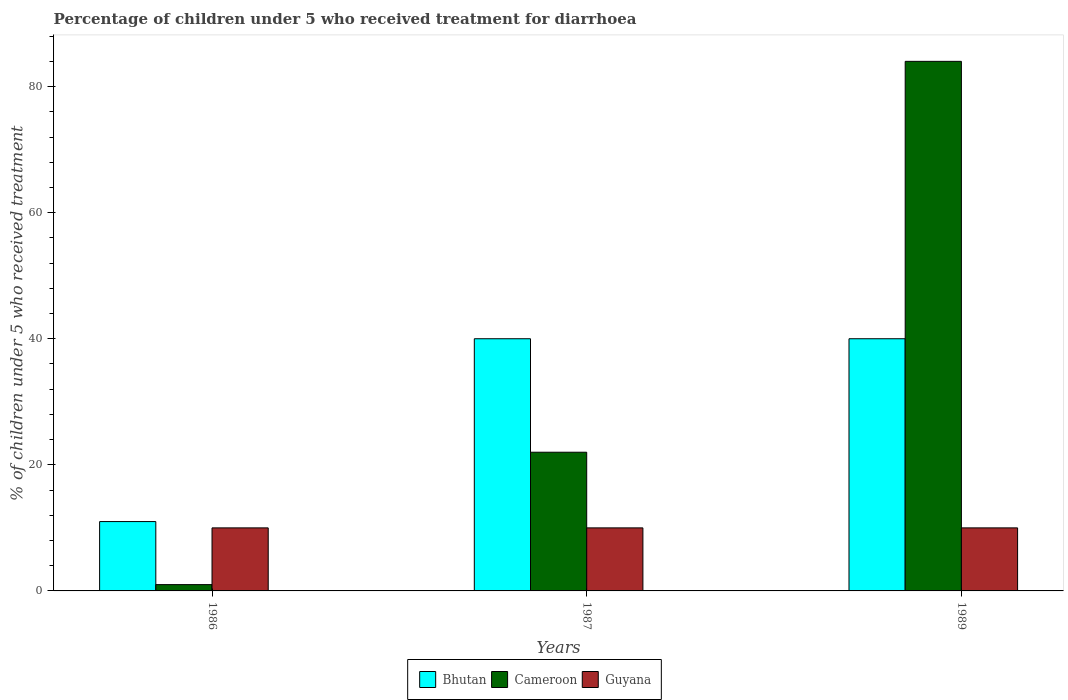How many different coloured bars are there?
Your answer should be compact. 3. Are the number of bars on each tick of the X-axis equal?
Ensure brevity in your answer.  Yes. What is the label of the 2nd group of bars from the left?
Ensure brevity in your answer.  1987. What is the percentage of children who received treatment for diarrhoea  in Cameroon in 1986?
Give a very brief answer. 1. Across all years, what is the maximum percentage of children who received treatment for diarrhoea  in Bhutan?
Offer a terse response. 40. In which year was the percentage of children who received treatment for diarrhoea  in Cameroon maximum?
Your response must be concise. 1989. In which year was the percentage of children who received treatment for diarrhoea  in Bhutan minimum?
Offer a very short reply. 1986. What is the total percentage of children who received treatment for diarrhoea  in Cameroon in the graph?
Offer a very short reply. 107. What is the difference between the percentage of children who received treatment for diarrhoea  in Cameroon in 1986 and that in 1987?
Give a very brief answer. -21. What is the difference between the percentage of children who received treatment for diarrhoea  in Cameroon in 1986 and the percentage of children who received treatment for diarrhoea  in Bhutan in 1987?
Provide a succinct answer. -39. What is the average percentage of children who received treatment for diarrhoea  in Guyana per year?
Your answer should be very brief. 10. In the year 1987, what is the difference between the percentage of children who received treatment for diarrhoea  in Cameroon and percentage of children who received treatment for diarrhoea  in Guyana?
Your response must be concise. 12. What is the ratio of the percentage of children who received treatment for diarrhoea  in Cameroon in 1986 to that in 1987?
Make the answer very short. 0.05. Is the percentage of children who received treatment for diarrhoea  in Guyana in 1986 less than that in 1987?
Keep it short and to the point. No. What is the difference between the highest and the second highest percentage of children who received treatment for diarrhoea  in Cameroon?
Offer a terse response. 62. What is the difference between the highest and the lowest percentage of children who received treatment for diarrhoea  in Guyana?
Your answer should be compact. 0. In how many years, is the percentage of children who received treatment for diarrhoea  in Bhutan greater than the average percentage of children who received treatment for diarrhoea  in Bhutan taken over all years?
Ensure brevity in your answer.  2. What does the 2nd bar from the left in 1989 represents?
Ensure brevity in your answer.  Cameroon. What does the 2nd bar from the right in 1986 represents?
Keep it short and to the point. Cameroon. Is it the case that in every year, the sum of the percentage of children who received treatment for diarrhoea  in Bhutan and percentage of children who received treatment for diarrhoea  in Guyana is greater than the percentage of children who received treatment for diarrhoea  in Cameroon?
Your answer should be very brief. No. How many bars are there?
Provide a short and direct response. 9. What is the difference between two consecutive major ticks on the Y-axis?
Ensure brevity in your answer.  20. Are the values on the major ticks of Y-axis written in scientific E-notation?
Your response must be concise. No. Where does the legend appear in the graph?
Give a very brief answer. Bottom center. How are the legend labels stacked?
Make the answer very short. Horizontal. What is the title of the graph?
Your answer should be very brief. Percentage of children under 5 who received treatment for diarrhoea. What is the label or title of the X-axis?
Your response must be concise. Years. What is the label or title of the Y-axis?
Provide a succinct answer. % of children under 5 who received treatment. What is the % of children under 5 who received treatment in Cameroon in 1986?
Keep it short and to the point. 1. What is the % of children under 5 who received treatment in Guyana in 1986?
Offer a very short reply. 10. What is the % of children under 5 who received treatment of Bhutan in 1987?
Provide a short and direct response. 40. What is the % of children under 5 who received treatment in Cameroon in 1987?
Keep it short and to the point. 22. What is the % of children under 5 who received treatment in Guyana in 1987?
Ensure brevity in your answer.  10. Across all years, what is the maximum % of children under 5 who received treatment in Cameroon?
Offer a very short reply. 84. Across all years, what is the maximum % of children under 5 who received treatment of Guyana?
Your answer should be compact. 10. Across all years, what is the minimum % of children under 5 who received treatment of Bhutan?
Your answer should be very brief. 11. Across all years, what is the minimum % of children under 5 who received treatment of Cameroon?
Your answer should be compact. 1. Across all years, what is the minimum % of children under 5 who received treatment in Guyana?
Your response must be concise. 10. What is the total % of children under 5 who received treatment of Bhutan in the graph?
Your response must be concise. 91. What is the total % of children under 5 who received treatment of Cameroon in the graph?
Your answer should be compact. 107. What is the difference between the % of children under 5 who received treatment of Guyana in 1986 and that in 1987?
Offer a terse response. 0. What is the difference between the % of children under 5 who received treatment of Cameroon in 1986 and that in 1989?
Offer a very short reply. -83. What is the difference between the % of children under 5 who received treatment of Cameroon in 1987 and that in 1989?
Provide a short and direct response. -62. What is the difference between the % of children under 5 who received treatment of Bhutan in 1986 and the % of children under 5 who received treatment of Cameroon in 1987?
Your response must be concise. -11. What is the difference between the % of children under 5 who received treatment in Bhutan in 1986 and the % of children under 5 who received treatment in Cameroon in 1989?
Keep it short and to the point. -73. What is the difference between the % of children under 5 who received treatment of Bhutan in 1986 and the % of children under 5 who received treatment of Guyana in 1989?
Provide a succinct answer. 1. What is the difference between the % of children under 5 who received treatment in Bhutan in 1987 and the % of children under 5 who received treatment in Cameroon in 1989?
Make the answer very short. -44. What is the difference between the % of children under 5 who received treatment in Cameroon in 1987 and the % of children under 5 who received treatment in Guyana in 1989?
Offer a very short reply. 12. What is the average % of children under 5 who received treatment of Bhutan per year?
Provide a succinct answer. 30.33. What is the average % of children under 5 who received treatment of Cameroon per year?
Your response must be concise. 35.67. In the year 1986, what is the difference between the % of children under 5 who received treatment of Bhutan and % of children under 5 who received treatment of Cameroon?
Offer a very short reply. 10. In the year 1986, what is the difference between the % of children under 5 who received treatment of Bhutan and % of children under 5 who received treatment of Guyana?
Offer a terse response. 1. In the year 1986, what is the difference between the % of children under 5 who received treatment of Cameroon and % of children under 5 who received treatment of Guyana?
Keep it short and to the point. -9. In the year 1989, what is the difference between the % of children under 5 who received treatment in Bhutan and % of children under 5 who received treatment in Cameroon?
Give a very brief answer. -44. In the year 1989, what is the difference between the % of children under 5 who received treatment of Cameroon and % of children under 5 who received treatment of Guyana?
Keep it short and to the point. 74. What is the ratio of the % of children under 5 who received treatment of Bhutan in 1986 to that in 1987?
Give a very brief answer. 0.28. What is the ratio of the % of children under 5 who received treatment in Cameroon in 1986 to that in 1987?
Keep it short and to the point. 0.05. What is the ratio of the % of children under 5 who received treatment in Guyana in 1986 to that in 1987?
Give a very brief answer. 1. What is the ratio of the % of children under 5 who received treatment of Bhutan in 1986 to that in 1989?
Provide a short and direct response. 0.28. What is the ratio of the % of children under 5 who received treatment in Cameroon in 1986 to that in 1989?
Provide a succinct answer. 0.01. What is the ratio of the % of children under 5 who received treatment in Bhutan in 1987 to that in 1989?
Keep it short and to the point. 1. What is the ratio of the % of children under 5 who received treatment of Cameroon in 1987 to that in 1989?
Your answer should be very brief. 0.26. What is the difference between the highest and the second highest % of children under 5 who received treatment of Cameroon?
Your response must be concise. 62. What is the difference between the highest and the lowest % of children under 5 who received treatment of Bhutan?
Your answer should be compact. 29. 